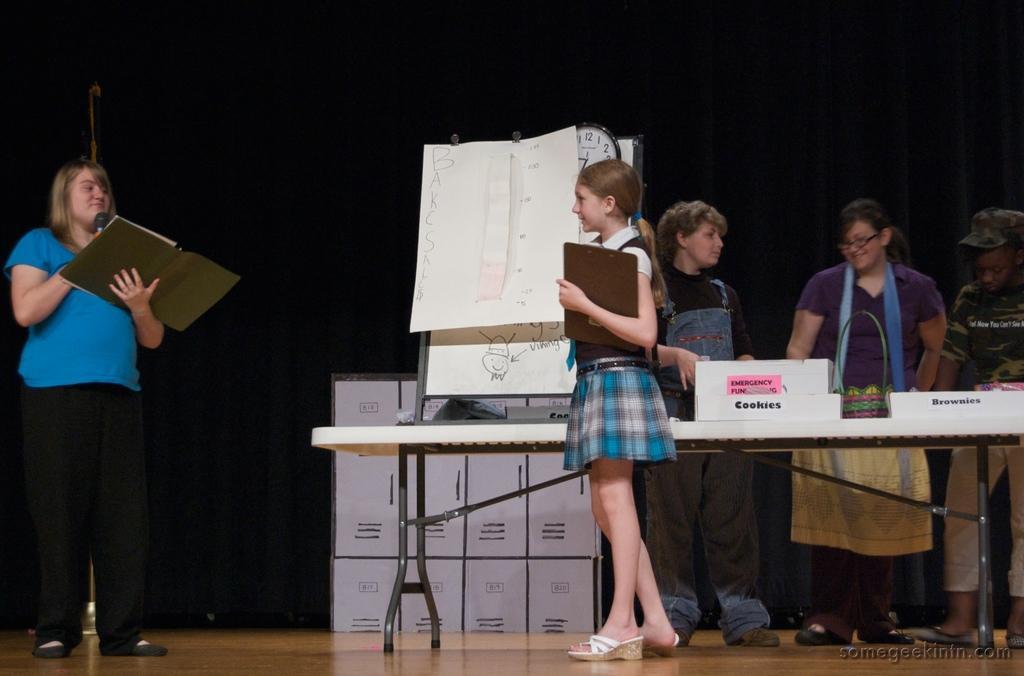Can you describe this image briefly? In this image there are 3 persons standing near the table ,another person standing, holding a book and a micro phone , in the background there are some cupboards and hoarding. 